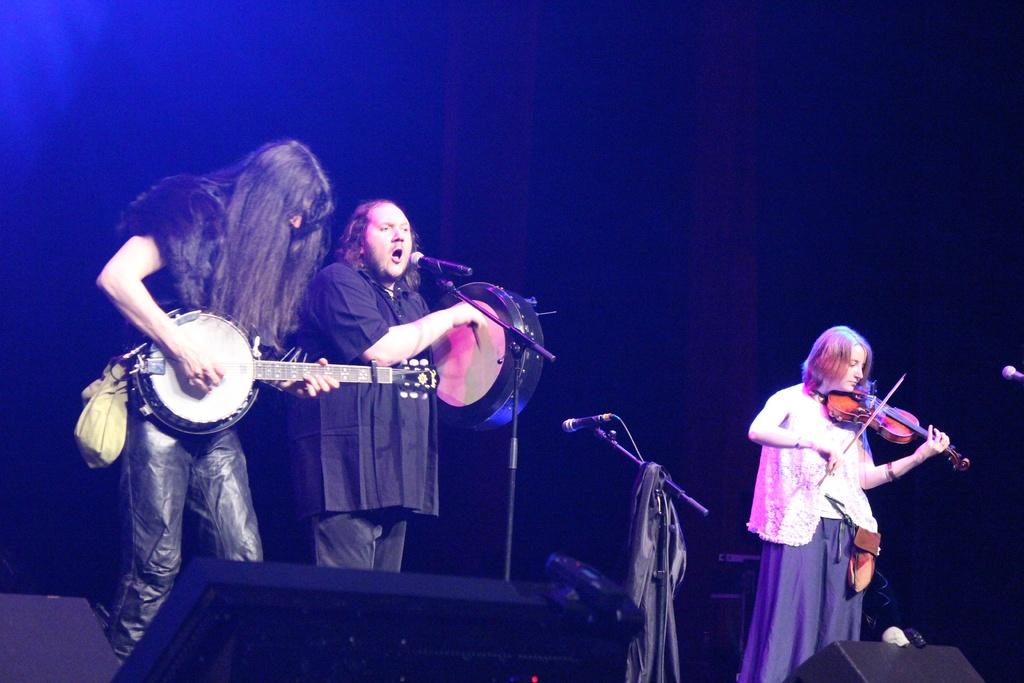What are the two persons in the image doing? The two persons in the image are playing guitar. What is the man with the microphone doing? The man with the microphone is singing. What instrument is the man with the microphone playing? The man with the microphone is also playing a musical instrument. How many microphones are visible in the image? There are microphones present in the image. How many seats are visible in the image? There is no mention of seats in the provided facts, so we cannot determine the number of seats in the image. Can you tell me how many times the man sneezes while singing? There is no indication of the man sneezing in the image, so we cannot determine the number of sneezes. 